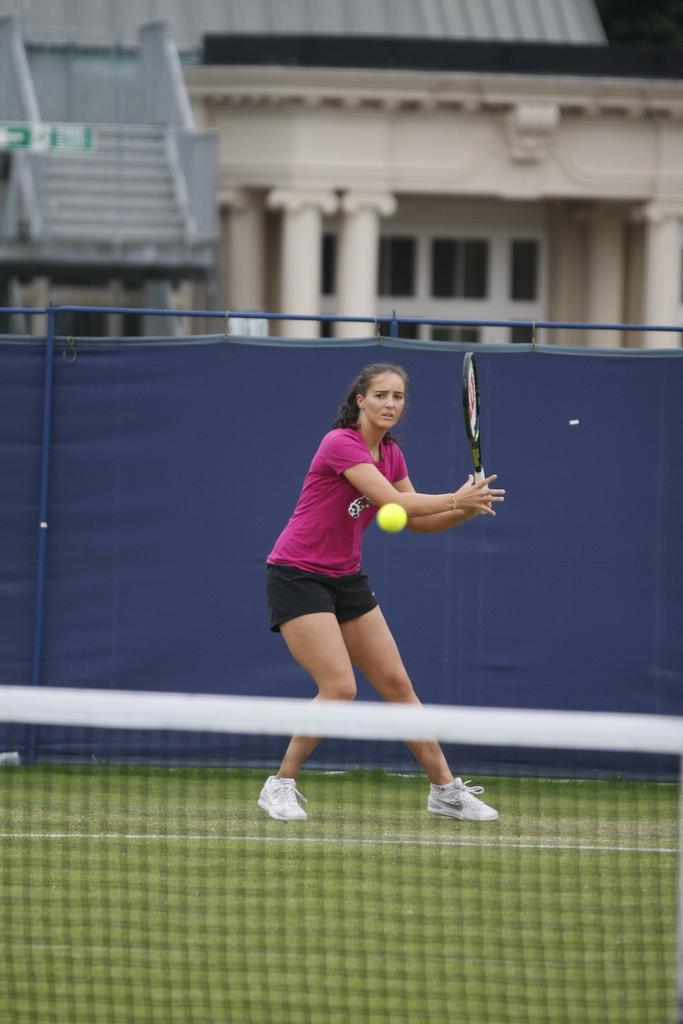Please provide a concise description of this image. In this picture there is a girl who is standing at the center of the image and she is playing the tennis, it seems to be a play ground and there is a building at the center of the image. 